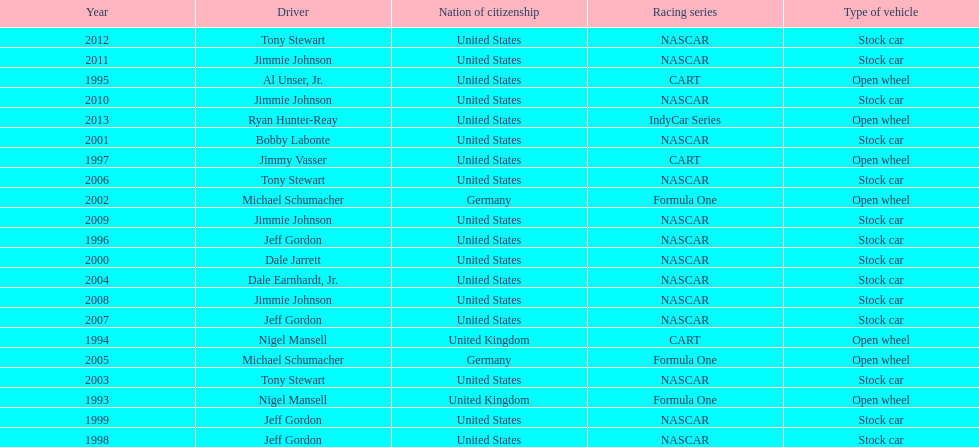Which racing series has the highest total of winners? NASCAR. Would you be able to parse every entry in this table? {'header': ['Year', 'Driver', 'Nation of citizenship', 'Racing series', 'Type of vehicle'], 'rows': [['2012', 'Tony Stewart', 'United States', 'NASCAR', 'Stock car'], ['2011', 'Jimmie Johnson', 'United States', 'NASCAR', 'Stock car'], ['1995', 'Al Unser, Jr.', 'United States', 'CART', 'Open wheel'], ['2010', 'Jimmie Johnson', 'United States', 'NASCAR', 'Stock car'], ['2013', 'Ryan Hunter-Reay', 'United States', 'IndyCar Series', 'Open wheel'], ['2001', 'Bobby Labonte', 'United States', 'NASCAR', 'Stock car'], ['1997', 'Jimmy Vasser', 'United States', 'CART', 'Open wheel'], ['2006', 'Tony Stewart', 'United States', 'NASCAR', 'Stock car'], ['2002', 'Michael Schumacher', 'Germany', 'Formula One', 'Open wheel'], ['2009', 'Jimmie Johnson', 'United States', 'NASCAR', 'Stock car'], ['1996', 'Jeff Gordon', 'United States', 'NASCAR', 'Stock car'], ['2000', 'Dale Jarrett', 'United States', 'NASCAR', 'Stock car'], ['2004', 'Dale Earnhardt, Jr.', 'United States', 'NASCAR', 'Stock car'], ['2008', 'Jimmie Johnson', 'United States', 'NASCAR', 'Stock car'], ['2007', 'Jeff Gordon', 'United States', 'NASCAR', 'Stock car'], ['1994', 'Nigel Mansell', 'United Kingdom', 'CART', 'Open wheel'], ['2005', 'Michael Schumacher', 'Germany', 'Formula One', 'Open wheel'], ['2003', 'Tony Stewart', 'United States', 'NASCAR', 'Stock car'], ['1993', 'Nigel Mansell', 'United Kingdom', 'Formula One', 'Open wheel'], ['1999', 'Jeff Gordon', 'United States', 'NASCAR', 'Stock car'], ['1998', 'Jeff Gordon', 'United States', 'NASCAR', 'Stock car']]} 